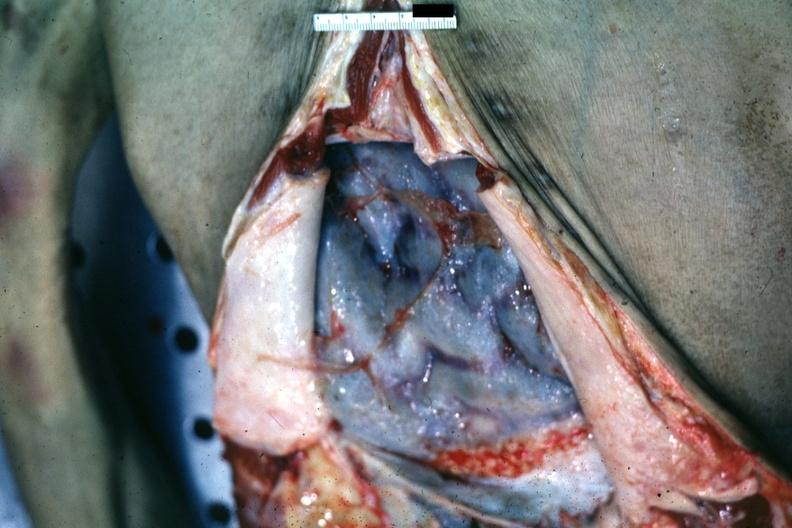does this image show opened abdomen with ischemic appearing intestines bound by neoplastic adhesions good but not the best ovarian papillary adenocarcinoma?
Answer the question using a single word or phrase. Yes 